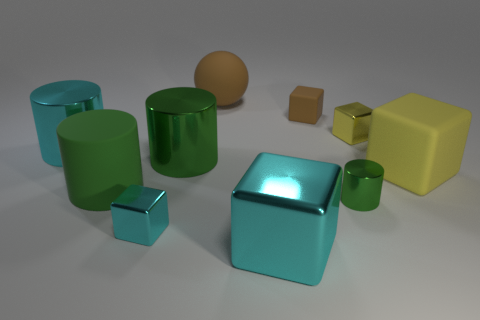Subtract all green cylinders. How many were subtracted if there are1green cylinders left? 2 Subtract all yellow spheres. How many green cylinders are left? 3 Subtract all brown blocks. How many blocks are left? 4 Subtract 1 cylinders. How many cylinders are left? 3 Subtract all blue blocks. Subtract all brown cylinders. How many blocks are left? 5 Subtract all cylinders. How many objects are left? 6 Subtract all small cyan balls. Subtract all large spheres. How many objects are left? 9 Add 5 yellow matte things. How many yellow matte things are left? 6 Add 7 gray blocks. How many gray blocks exist? 7 Subtract 0 purple spheres. How many objects are left? 10 